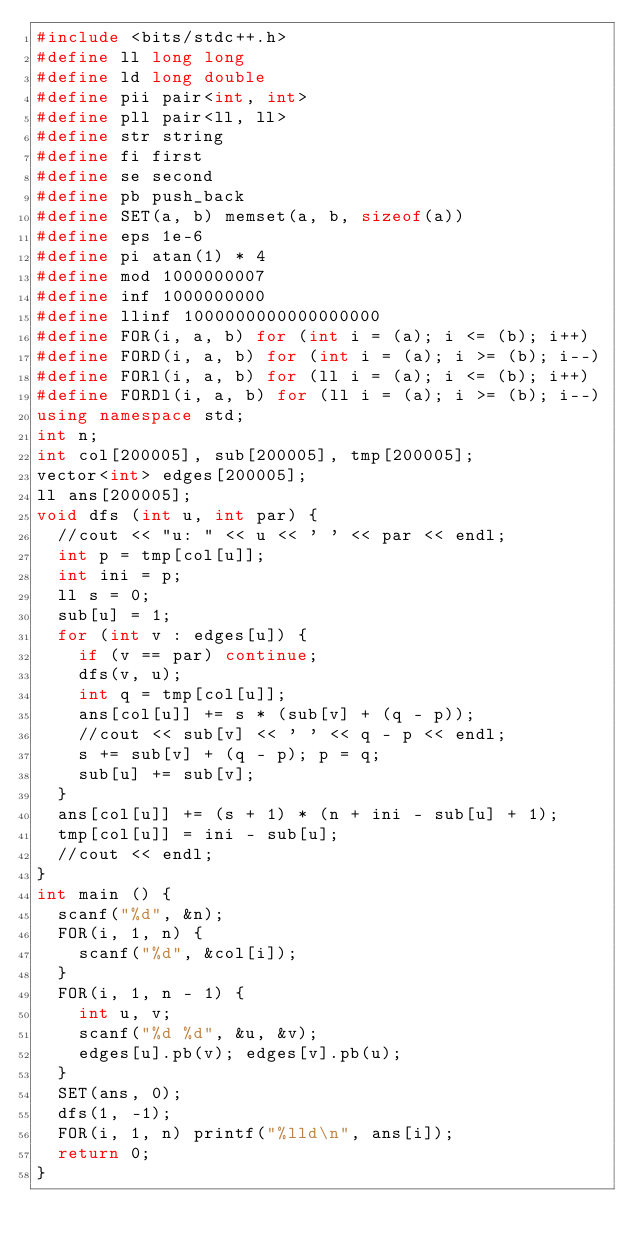<code> <loc_0><loc_0><loc_500><loc_500><_C++_>#include <bits/stdc++.h>
#define ll long long
#define ld long double
#define pii pair<int, int>
#define pll pair<ll, ll>
#define str string
#define fi first
#define se second
#define pb push_back
#define SET(a, b) memset(a, b, sizeof(a))
#define eps 1e-6
#define pi atan(1) * 4
#define mod 1000000007
#define inf 1000000000
#define llinf 1000000000000000000
#define FOR(i, a, b) for (int i = (a); i <= (b); i++)
#define FORD(i, a, b) for (int i = (a); i >= (b); i--)
#define FORl(i, a, b) for (ll i = (a); i <= (b); i++)
#define FORDl(i, a, b) for (ll i = (a); i >= (b); i--)
using namespace std;
int n;
int col[200005], sub[200005], tmp[200005];
vector<int> edges[200005];
ll ans[200005];
void dfs (int u, int par) {
  //cout << "u: " << u << ' ' << par << endl;
  int p = tmp[col[u]];
  int ini = p;
  ll s = 0;
  sub[u] = 1;
  for (int v : edges[u]) {
    if (v == par) continue;
    dfs(v, u);
    int q = tmp[col[u]];
    ans[col[u]] += s * (sub[v] + (q - p)); 
    //cout << sub[v] << ' ' << q - p << endl;
    s += sub[v] + (q - p); p = q;
    sub[u] += sub[v];
  }
  ans[col[u]] += (s + 1) * (n + ini - sub[u] + 1);
  tmp[col[u]] = ini - sub[u];
  //cout << endl;
}
int main () {
  scanf("%d", &n);
  FOR(i, 1, n) {
    scanf("%d", &col[i]);
  }
  FOR(i, 1, n - 1) {
    int u, v;
    scanf("%d %d", &u, &v);
    edges[u].pb(v); edges[v].pb(u);
  }
  SET(ans, 0);
  dfs(1, -1);
  FOR(i, 1, n) printf("%lld\n", ans[i]);
  return 0;
}</code> 